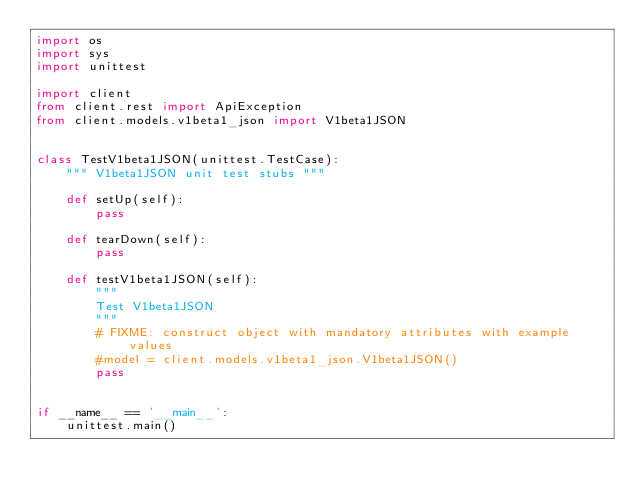Convert code to text. <code><loc_0><loc_0><loc_500><loc_500><_Python_>import os
import sys
import unittest

import client
from client.rest import ApiException
from client.models.v1beta1_json import V1beta1JSON


class TestV1beta1JSON(unittest.TestCase):
    """ V1beta1JSON unit test stubs """

    def setUp(self):
        pass

    def tearDown(self):
        pass

    def testV1beta1JSON(self):
        """
        Test V1beta1JSON
        """
        # FIXME: construct object with mandatory attributes with example values
        #model = client.models.v1beta1_json.V1beta1JSON()
        pass


if __name__ == '__main__':
    unittest.main()
</code> 